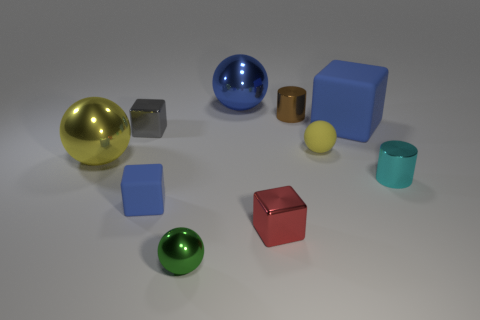Is the number of small red metallic things less than the number of red rubber blocks?
Keep it short and to the point. No. Is there a tiny blue sphere?
Your response must be concise. No. How many other things are there of the same size as the gray block?
Provide a short and direct response. 6. Is the small brown cylinder made of the same material as the small block that is on the left side of the tiny blue rubber cube?
Keep it short and to the point. Yes. Are there an equal number of tiny red things in front of the tiny cyan metal thing and tiny blue objects that are to the right of the tiny blue block?
Offer a terse response. No. What is the tiny blue cube made of?
Make the answer very short. Rubber. What color is the other metallic object that is the same size as the yellow shiny thing?
Ensure brevity in your answer.  Blue. Is there a large ball that is behind the small ball that is behind the green object?
Offer a terse response. Yes. How many cylinders are either tiny gray metallic objects or blue objects?
Offer a very short reply. 0. What size is the shiny ball to the left of the matte object that is in front of the metallic cylinder that is in front of the gray shiny cube?
Offer a terse response. Large. 